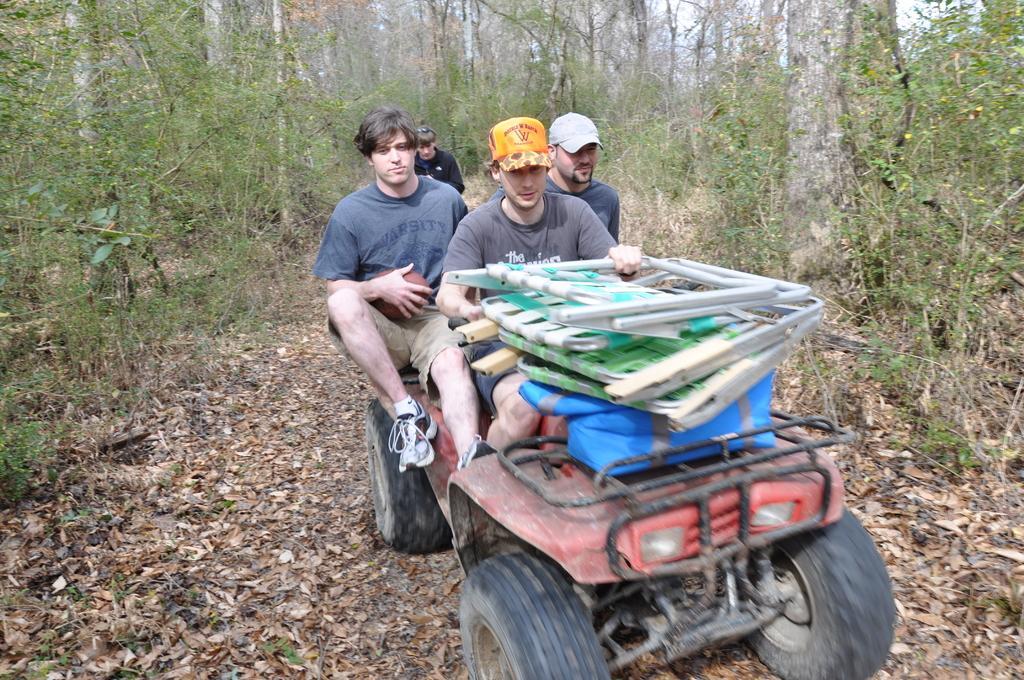Please provide a concise description of this image. In this image I can see group of people sitting in the vehicle and I can see few objects on the vehicle. In the background I can see few trees in green color and the sky is in white color. 